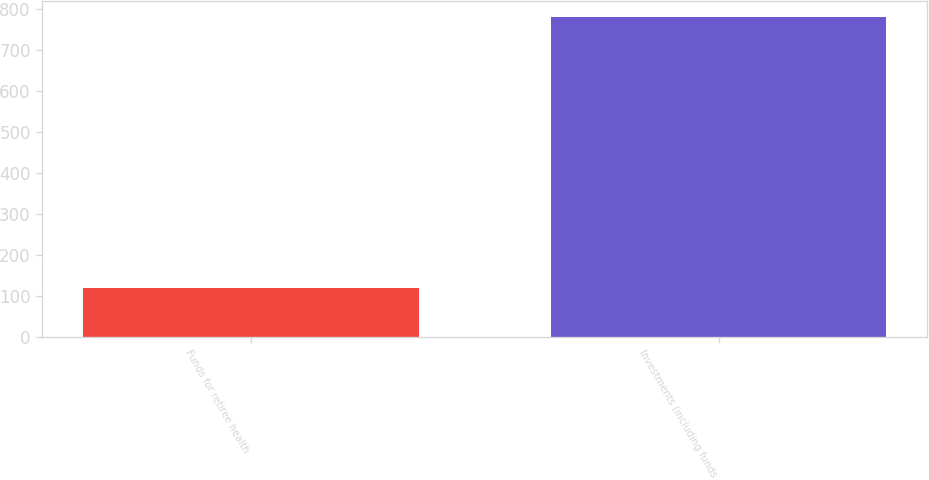Convert chart. <chart><loc_0><loc_0><loc_500><loc_500><bar_chart><fcel>Funds for retiree health<fcel>Investments (including funds<nl><fcel>120<fcel>780<nl></chart> 